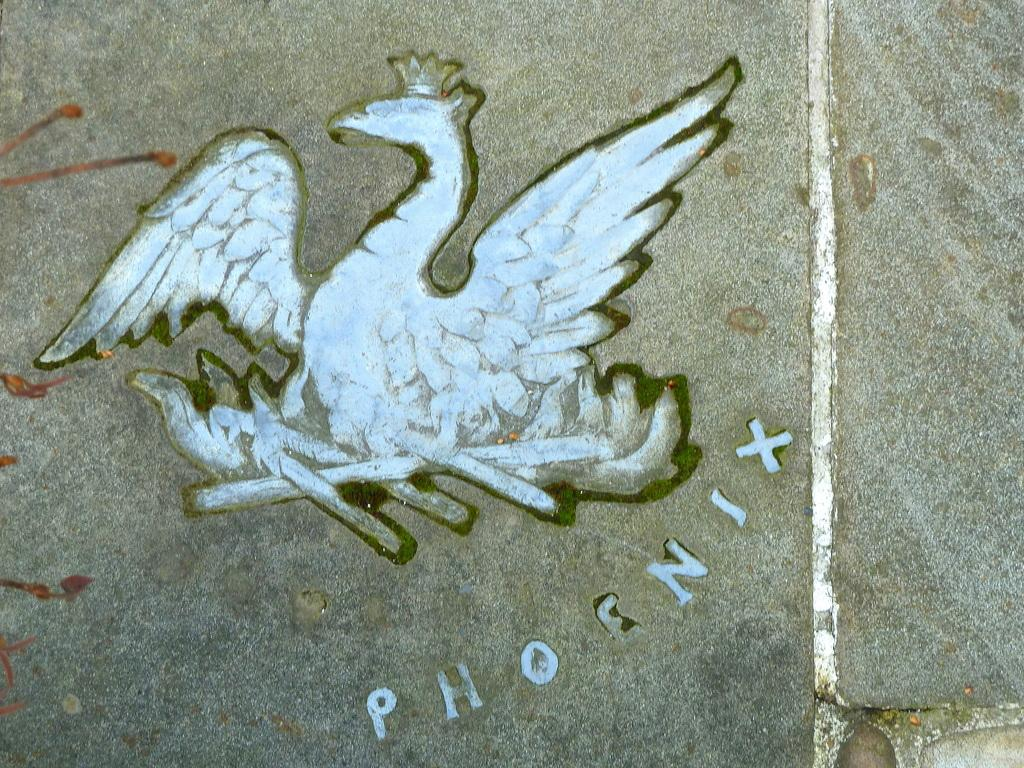What is present on the wall in the image? There is a painting on the wall in the image. What else can be seen on the wall besides the painting? There is text in the image. What type of motion is depicted in the painting on the wall? The painting on the wall does not depict any motion, as it is a static image. What color is the shirt worn by the person in the painting on the wall? There is no person or shirt visible in the painting on the wall, as it is not mentioned in the provided facts. 